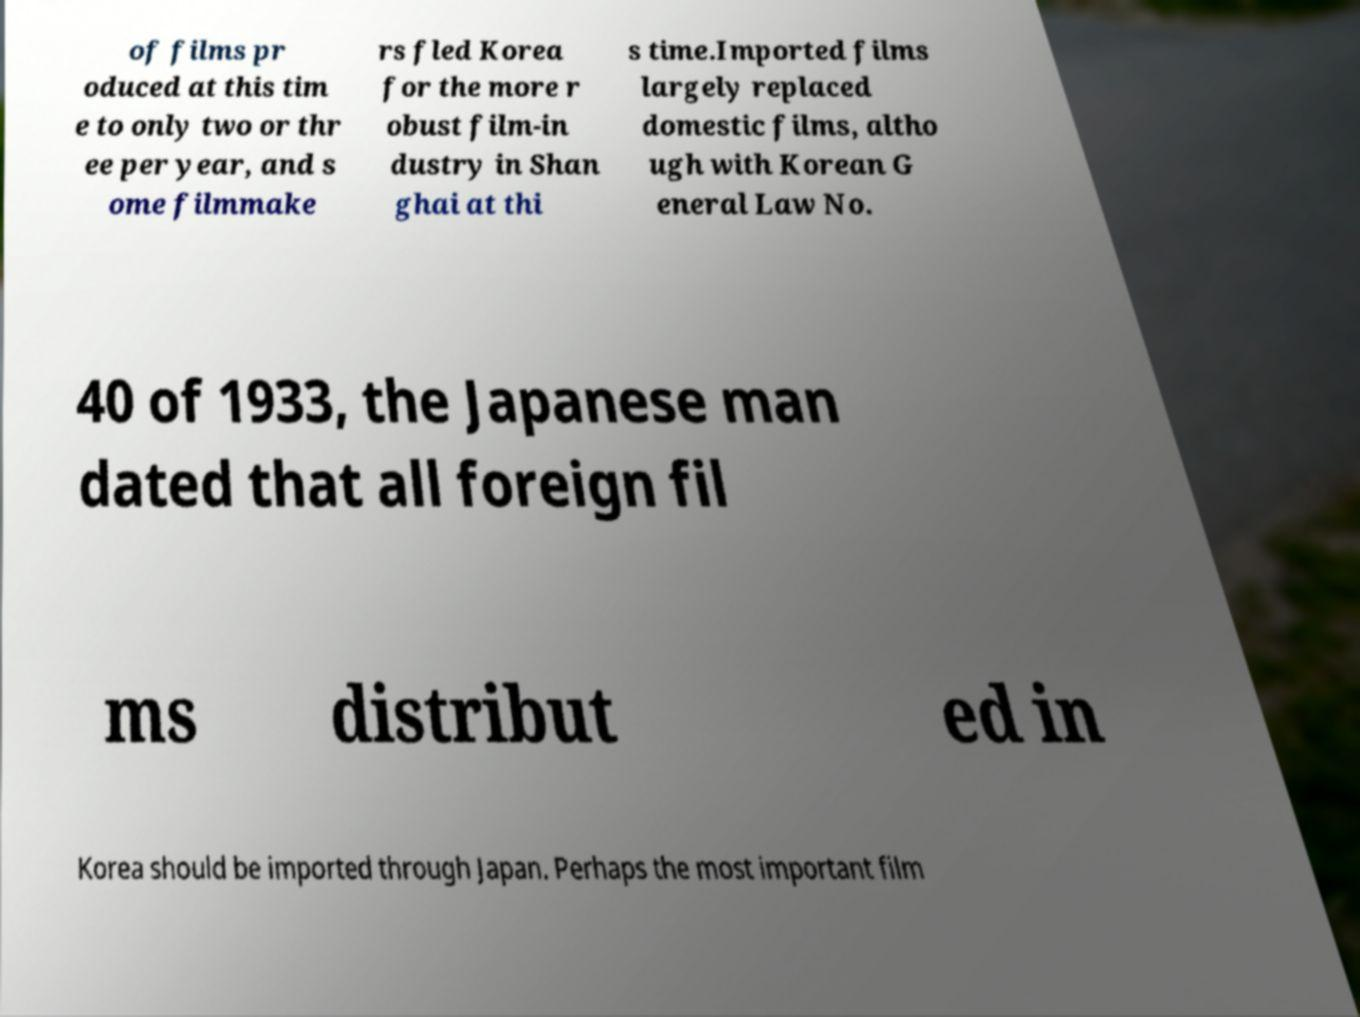Can you read and provide the text displayed in the image?This photo seems to have some interesting text. Can you extract and type it out for me? of films pr oduced at this tim e to only two or thr ee per year, and s ome filmmake rs fled Korea for the more r obust film-in dustry in Shan ghai at thi s time.Imported films largely replaced domestic films, altho ugh with Korean G eneral Law No. 40 of 1933, the Japanese man dated that all foreign fil ms distribut ed in Korea should be imported through Japan. Perhaps the most important film 